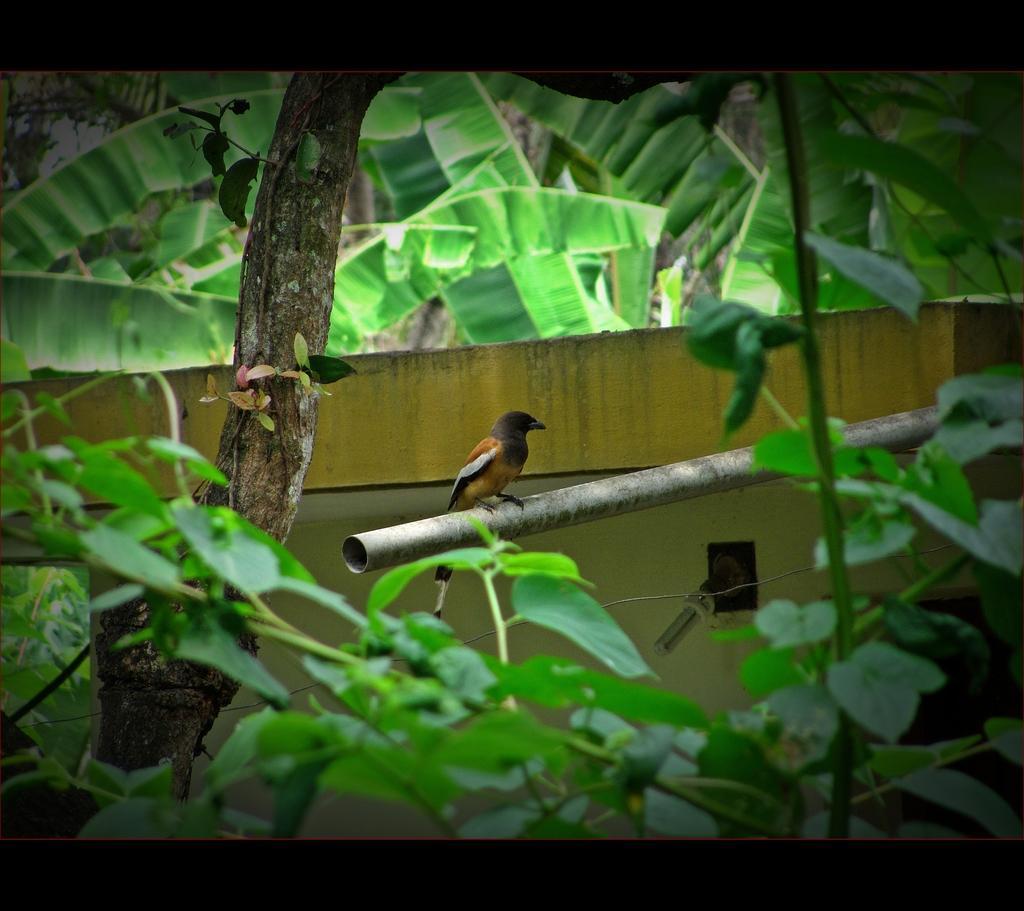How would you summarize this image in a sentence or two? Here in this picture we can see a bird present on a pole and we can also see plants and trees present over there. 